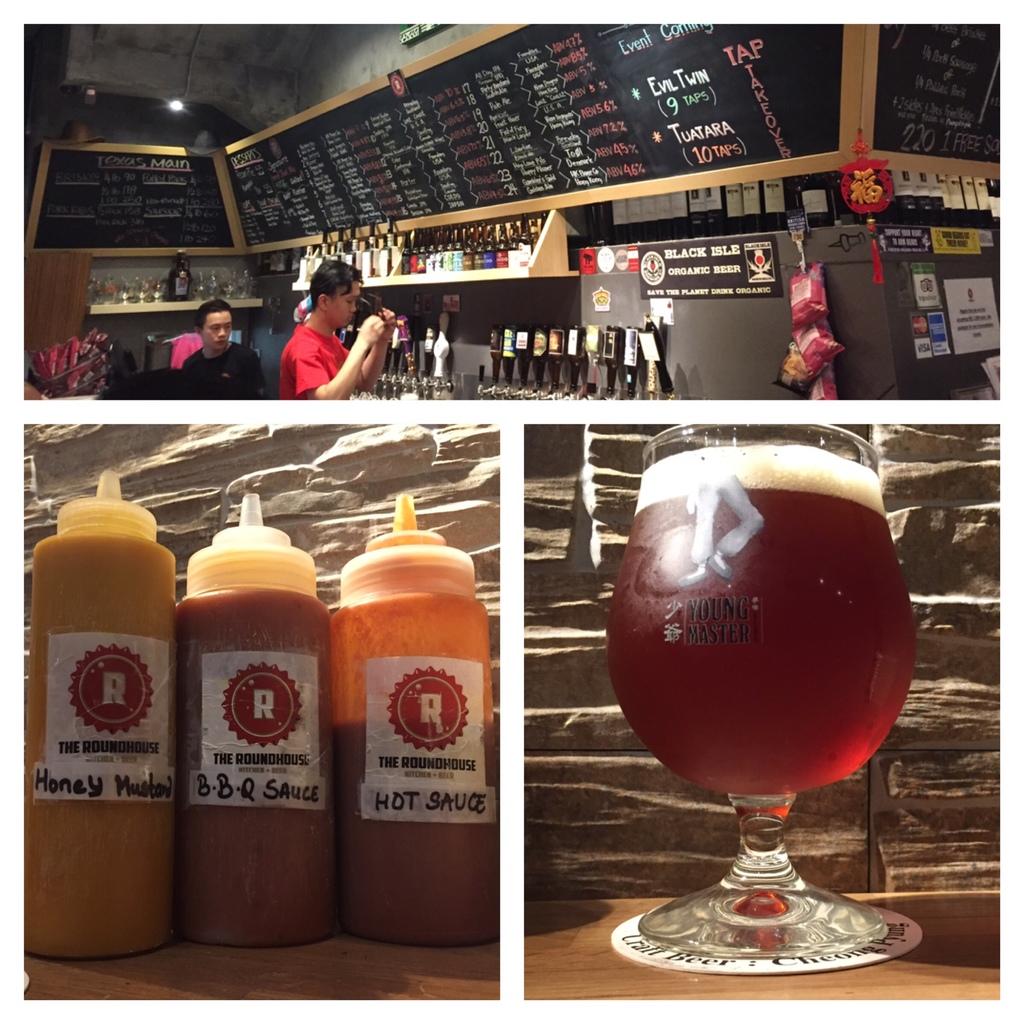What is in the bottle on the left?
Make the answer very short. Honey mustard. 